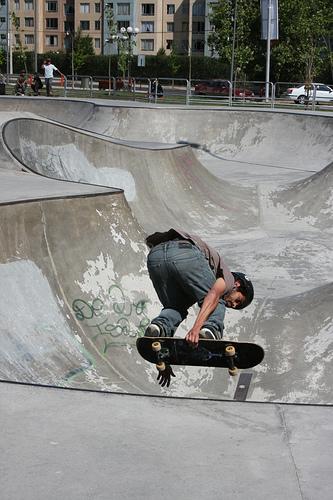Did the guy get stuck on his skateboard?
Be succinct. No. Is the skateboarder about to fall?
Concise answer only. No. What color is the writing on the ramp?
Quick response, please. Green. How many bicycles are there?
Be succinct. 0. 